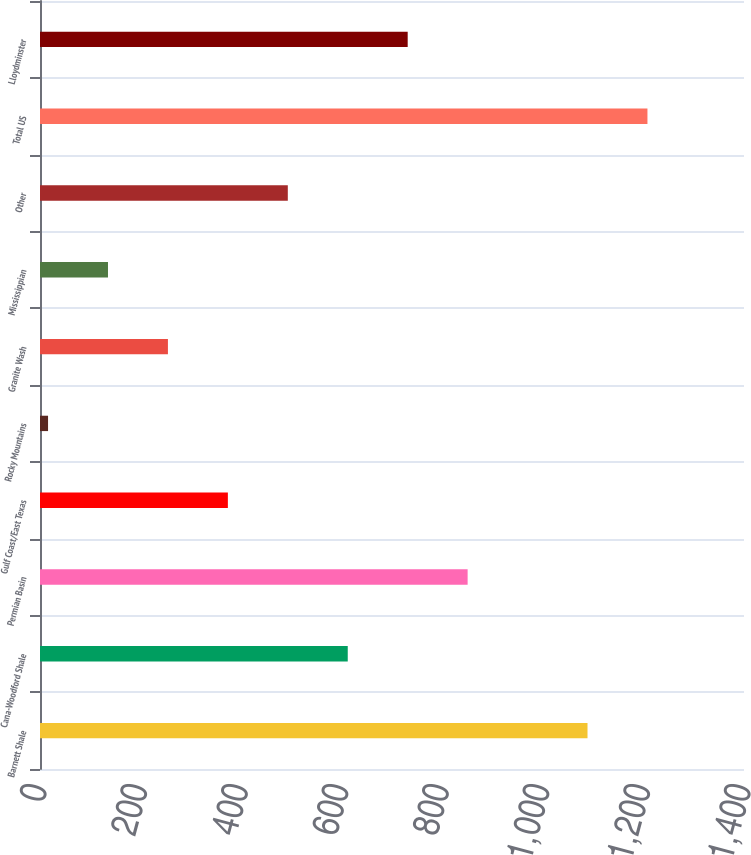Convert chart. <chart><loc_0><loc_0><loc_500><loc_500><bar_chart><fcel>Barnett Shale<fcel>Cana-Woodford Shale<fcel>Permian Basin<fcel>Gulf Coast/East Texas<fcel>Rocky Mountains<fcel>Granite Wash<fcel>Mississippian<fcel>Other<fcel>Total US<fcel>Lloydminster<nl><fcel>1088.8<fcel>612<fcel>850.4<fcel>373.6<fcel>16<fcel>254.4<fcel>135.2<fcel>492.8<fcel>1208<fcel>731.2<nl></chart> 